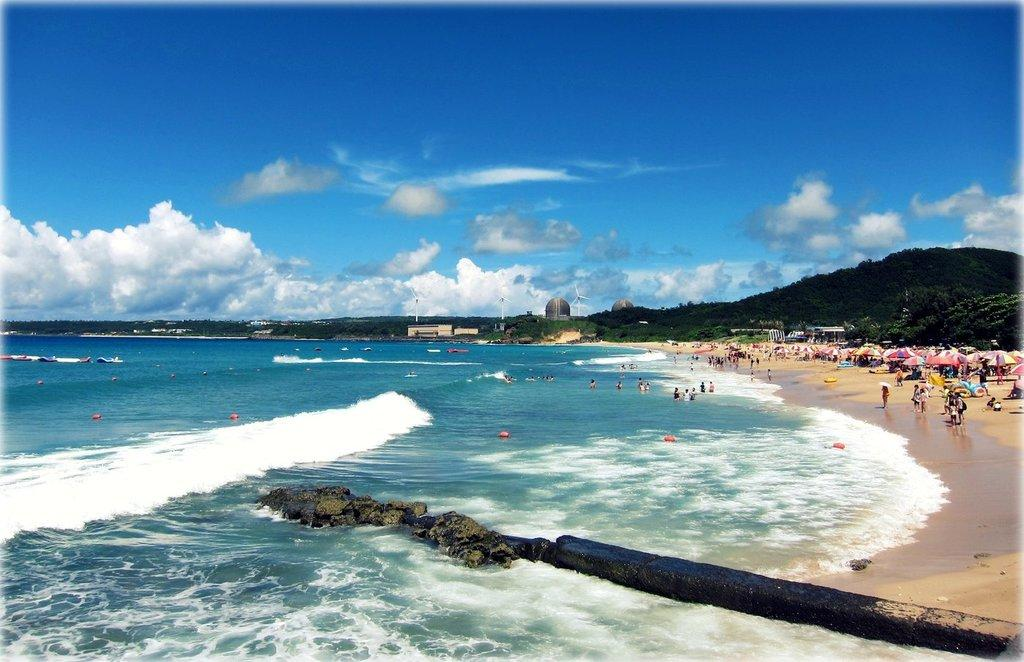What are the people in the image doing? There is a group of people in the water in the image. What objects can be seen in the image besides the people? There are umbrellas, trees, buildings, windmills, and hills visible in the image. What is visible in the background of the image? The sky is visible in the background of the image. How many snakes are present in the image? There are no snakes present in the image. What type of bait is being used by the people in the image? There is no indication of fishing or bait in the image; the people are in the water, and there are no fishing-related objects or activities depicted. 